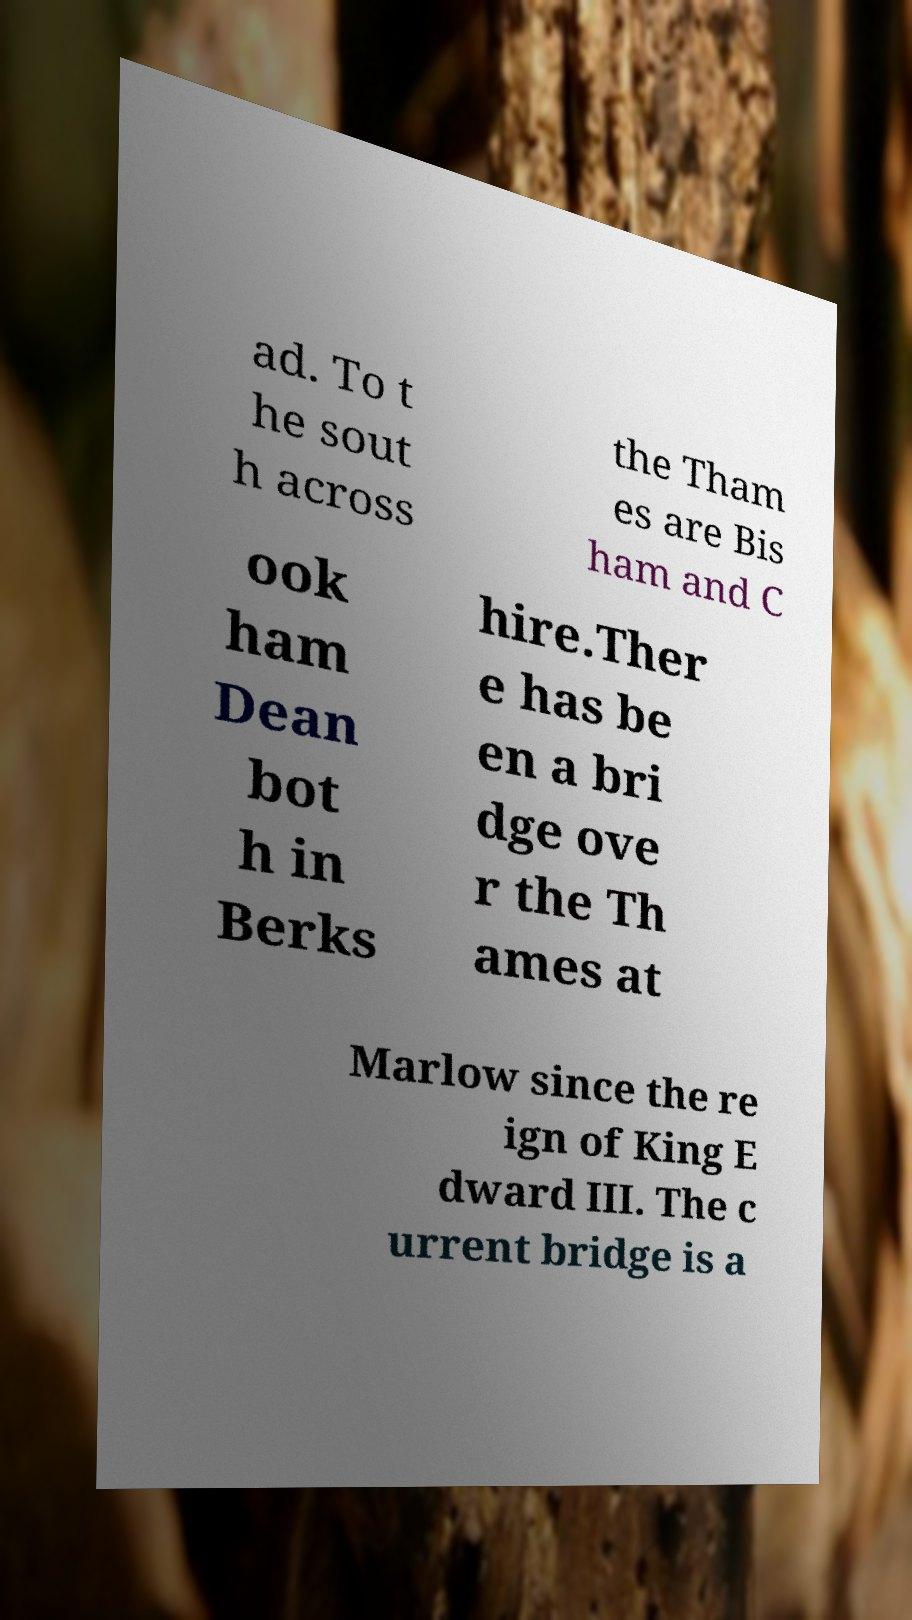I need the written content from this picture converted into text. Can you do that? ad. To t he sout h across the Tham es are Bis ham and C ook ham Dean bot h in Berks hire.Ther e has be en a bri dge ove r the Th ames at Marlow since the re ign of King E dward III. The c urrent bridge is a 